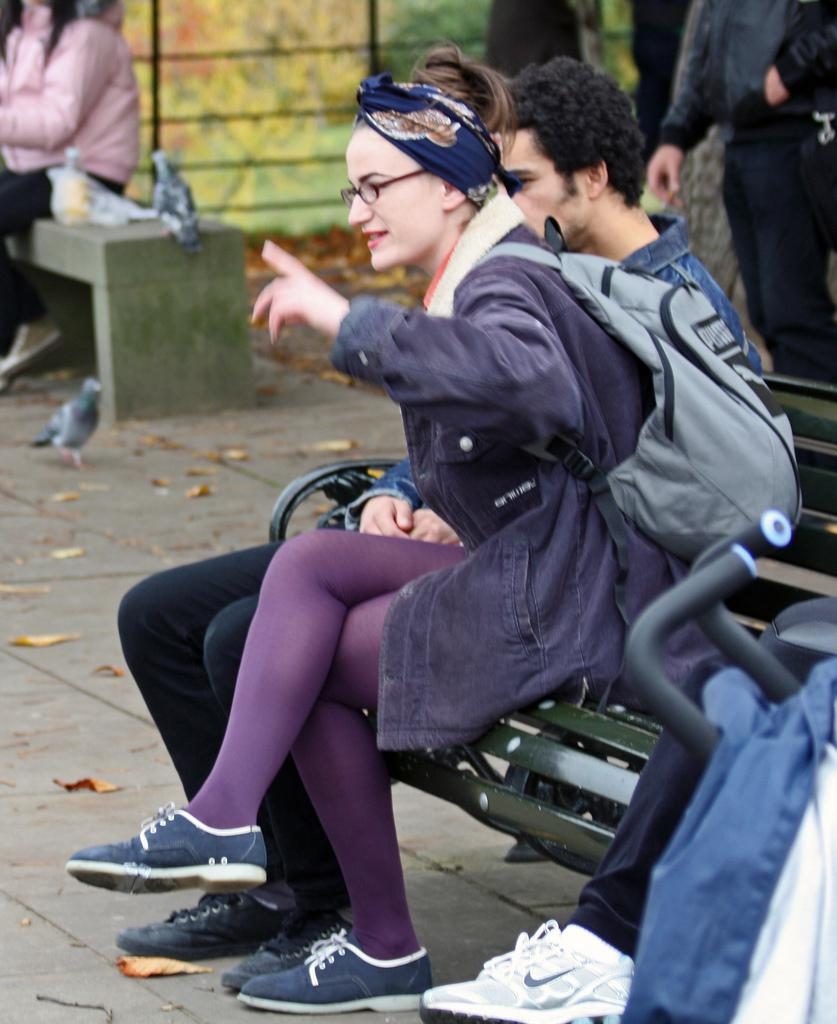Question: what is the total number of people wearing purple tights?
Choices:
A. Just one.
B. Two.
C. Five.
D. Ten.
Answer with the letter. Answer: A Question: where is the woman in purple tights?
Choices:
A. On a green bench, next to a curly-haired man.
B. Sitting on a stool.
C. Sitting by a man on a pew.
D. On benches my men.
Answer with the letter. Answer: A Question: who has curly hair?
Choices:
A. The boy.
B. The man.
C. The man on the green bench, beside the woman in the purple tights.
D. The woman.
Answer with the letter. Answer: C Question: when will the two people on the bench get up?
Choices:
A. When they decide to go somewhere else.
B. When they are ready.
C. When they leave.
D. When it's time.
Answer with the letter. Answer: A Question: what does the woman in purple tights have on her back?
Choices:
A. A backpack.
B. A purse.
C. A bag.
D. A knapsack.
Answer with the letter. Answer: D Question: how many knapsacks does the woman in tights have?
Choices:
A. Only one.
B. A few.
C. Very little.
D. None.
Answer with the letter. Answer: A Question: who is the focus of the picture?
Choices:
A. The man with the red hat.
B. The lady in orange.
C. The child in blue.
D. The woman with glasses.
Answer with the letter. Answer: D Question: where are the birds?
Choices:
A. On the statue.
B. In a tree.
C. In the sky.
D. Next to the people.
Answer with the letter. Answer: D Question: who is wearing tights?
Choices:
A. The girl.
B. Peter pan.
C. Ballerina.
D. The boy.
Answer with the letter. Answer: A Question: where is the man?
Choices:
A. At the table.
B. In the chair.
C. In the park.
D. Next to the woman.
Answer with the letter. Answer: D Question: who is wearing a scarf?
Choices:
A. The girl.
B. The kids.
C. The lady.
D. The woman.
Answer with the letter. Answer: D Question: who has curly hair?
Choices:
A. The poodle.
B. The baby girl.
C. The lamb.
D. The man.
Answer with the letter. Answer: D Question: what is the girl wearing?
Choices:
A. Pink pinafore.
B. Red sweater.
C. Blue sneakers.
D. Green overalls.
Answer with the letter. Answer: C Question: what color are the girl's leggings?
Choices:
A. Pink.
B. Blue.
C. Green.
D. Purple.
Answer with the letter. Answer: D Question: what birds are in the background?
Choices:
A. Bluebirds.
B. Eagles.
C. Pigeons.
D. Hawks.
Answer with the letter. Answer: C Question: what brand is the girl's backpack?
Choices:
A. Puma.
B. Nike.
C. Reebok.
D. Pearl Izumi.
Answer with the letter. Answer: A Question: how many backpacks is the girl wearing?
Choices:
A. One.
B. Two.
C. Three.
D. Four.
Answer with the letter. Answer: A 